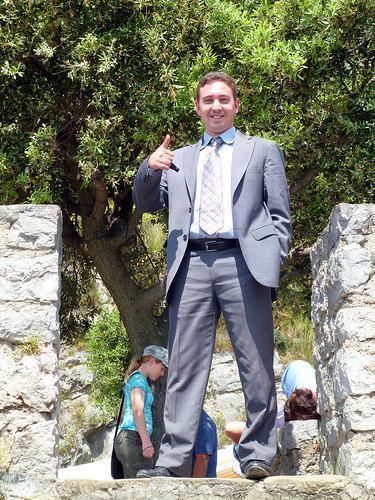How many people are wearing hat?
Give a very brief answer. 1. 